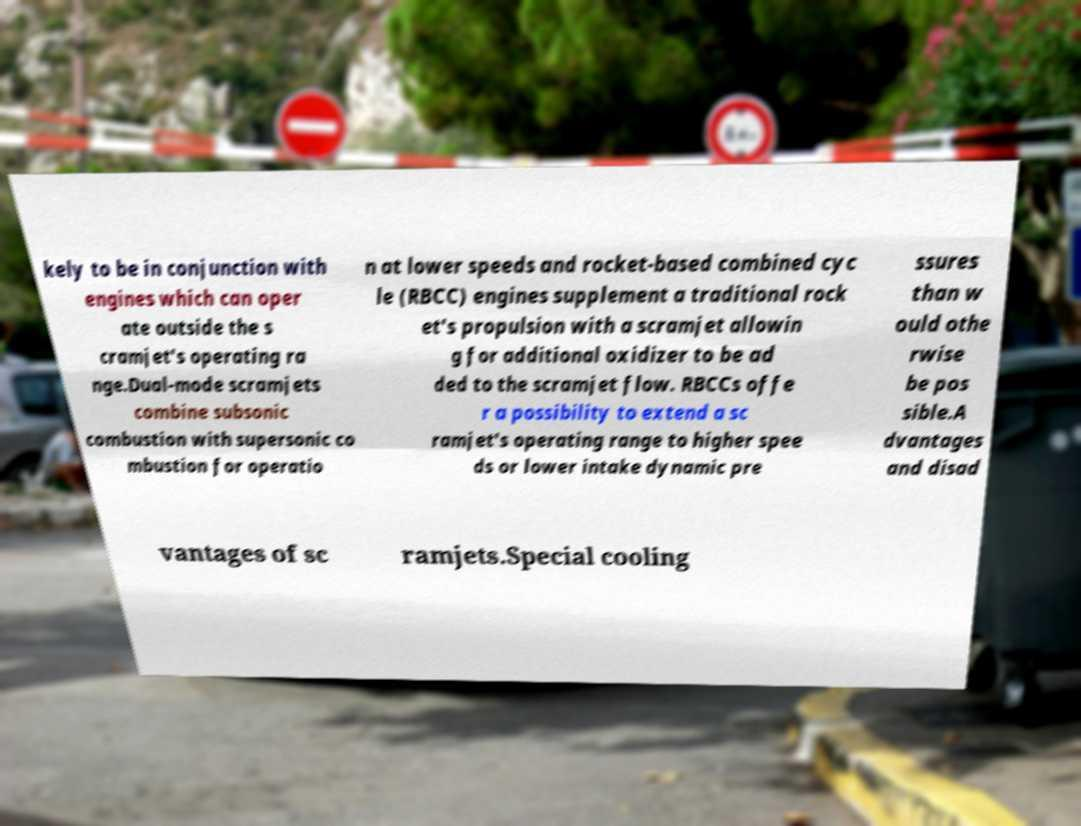Can you accurately transcribe the text from the provided image for me? kely to be in conjunction with engines which can oper ate outside the s cramjet's operating ra nge.Dual-mode scramjets combine subsonic combustion with supersonic co mbustion for operatio n at lower speeds and rocket-based combined cyc le (RBCC) engines supplement a traditional rock et's propulsion with a scramjet allowin g for additional oxidizer to be ad ded to the scramjet flow. RBCCs offe r a possibility to extend a sc ramjet's operating range to higher spee ds or lower intake dynamic pre ssures than w ould othe rwise be pos sible.A dvantages and disad vantages of sc ramjets.Special cooling 